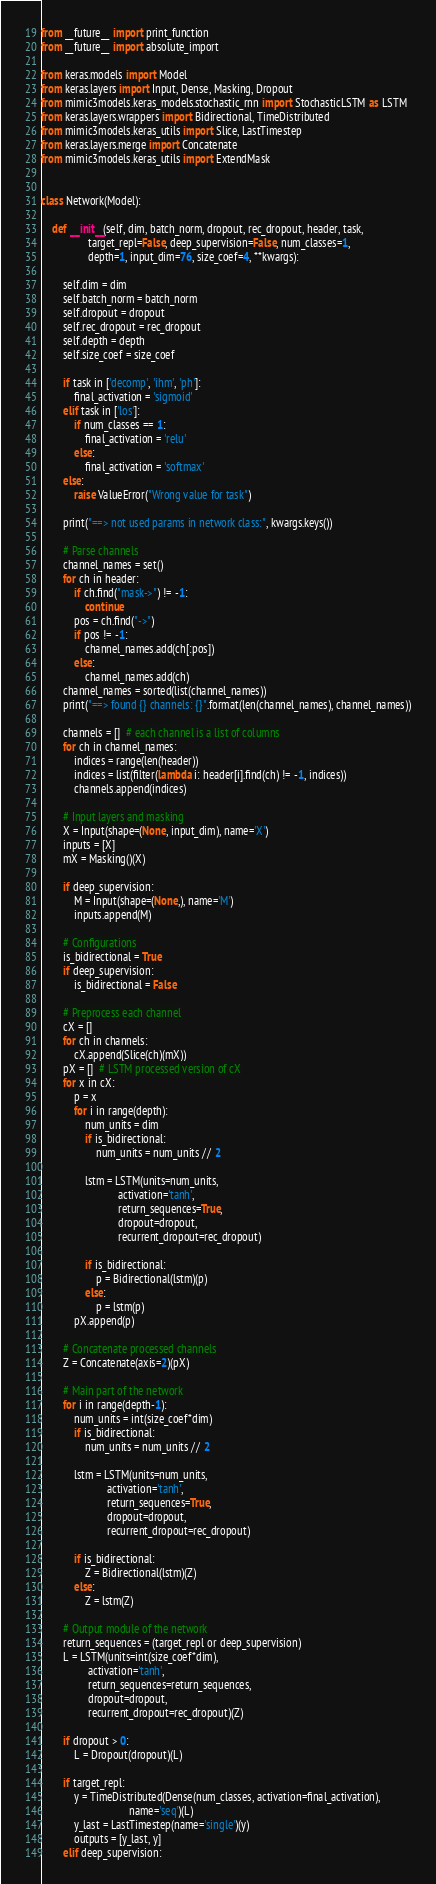<code> <loc_0><loc_0><loc_500><loc_500><_Python_>from __future__ import print_function
from __future__ import absolute_import

from keras.models import Model
from keras.layers import Input, Dense, Masking, Dropout
from mimic3models.keras_models.stochastic_rnn import StochasticLSTM as LSTM
from keras.layers.wrappers import Bidirectional, TimeDistributed
from mimic3models.keras_utils import Slice, LastTimestep
from keras.layers.merge import Concatenate
from mimic3models.keras_utils import ExtendMask


class Network(Model):

    def __init__(self, dim, batch_norm, dropout, rec_dropout, header, task,
                 target_repl=False, deep_supervision=False, num_classes=1,
                 depth=1, input_dim=76, size_coef=4, **kwargs):

        self.dim = dim
        self.batch_norm = batch_norm
        self.dropout = dropout
        self.rec_dropout = rec_dropout
        self.depth = depth
        self.size_coef = size_coef

        if task in ['decomp', 'ihm', 'ph']:
            final_activation = 'sigmoid'
        elif task in ['los']:
            if num_classes == 1:
                final_activation = 'relu'
            else:
                final_activation = 'softmax'
        else:
            raise ValueError("Wrong value for task")

        print("==> not used params in network class:", kwargs.keys())

        # Parse channels
        channel_names = set()
        for ch in header:
            if ch.find("mask->") != -1:
                continue
            pos = ch.find("->")
            if pos != -1:
                channel_names.add(ch[:pos])
            else:
                channel_names.add(ch)
        channel_names = sorted(list(channel_names))
        print("==> found {} channels: {}".format(len(channel_names), channel_names))

        channels = []  # each channel is a list of columns
        for ch in channel_names:
            indices = range(len(header))
            indices = list(filter(lambda i: header[i].find(ch) != -1, indices))
            channels.append(indices)

        # Input layers and masking
        X = Input(shape=(None, input_dim), name='X')
        inputs = [X]
        mX = Masking()(X)

        if deep_supervision:
            M = Input(shape=(None,), name='M')
            inputs.append(M)

        # Configurations
        is_bidirectional = True
        if deep_supervision:
            is_bidirectional = False

        # Preprocess each channel
        cX = []
        for ch in channels:
            cX.append(Slice(ch)(mX))
        pX = []  # LSTM processed version of cX
        for x in cX:
            p = x
            for i in range(depth):
                num_units = dim
                if is_bidirectional:
                    num_units = num_units // 2

                lstm = LSTM(units=num_units,
                            activation='tanh',
                            return_sequences=True,
                            dropout=dropout,
                            recurrent_dropout=rec_dropout)

                if is_bidirectional:
                    p = Bidirectional(lstm)(p)
                else:
                    p = lstm(p)
            pX.append(p)

        # Concatenate processed channels
        Z = Concatenate(axis=2)(pX)

        # Main part of the network
        for i in range(depth-1):
            num_units = int(size_coef*dim)
            if is_bidirectional:
                num_units = num_units // 2

            lstm = LSTM(units=num_units,
                        activation='tanh',
                        return_sequences=True,
                        dropout=dropout,
                        recurrent_dropout=rec_dropout)

            if is_bidirectional:
                Z = Bidirectional(lstm)(Z)
            else:
                Z = lstm(Z)

        # Output module of the network
        return_sequences = (target_repl or deep_supervision)
        L = LSTM(units=int(size_coef*dim),
                 activation='tanh',
                 return_sequences=return_sequences,
                 dropout=dropout,
                 recurrent_dropout=rec_dropout)(Z)

        if dropout > 0:
            L = Dropout(dropout)(L)

        if target_repl:
            y = TimeDistributed(Dense(num_classes, activation=final_activation),
                                name='seq')(L)
            y_last = LastTimestep(name='single')(y)
            outputs = [y_last, y]
        elif deep_supervision:</code> 